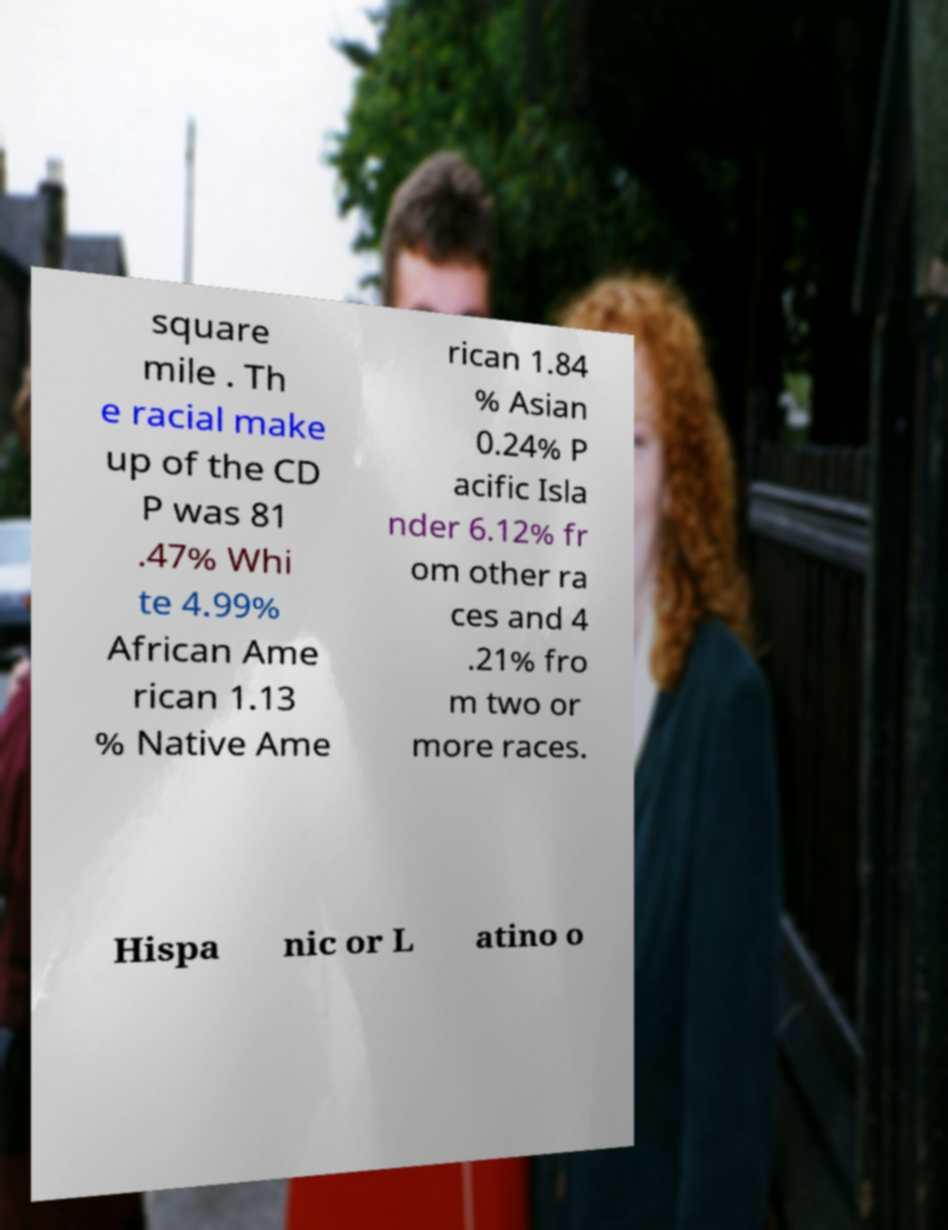Please read and relay the text visible in this image. What does it say? square mile . Th e racial make up of the CD P was 81 .47% Whi te 4.99% African Ame rican 1.13 % Native Ame rican 1.84 % Asian 0.24% P acific Isla nder 6.12% fr om other ra ces and 4 .21% fro m two or more races. Hispa nic or L atino o 